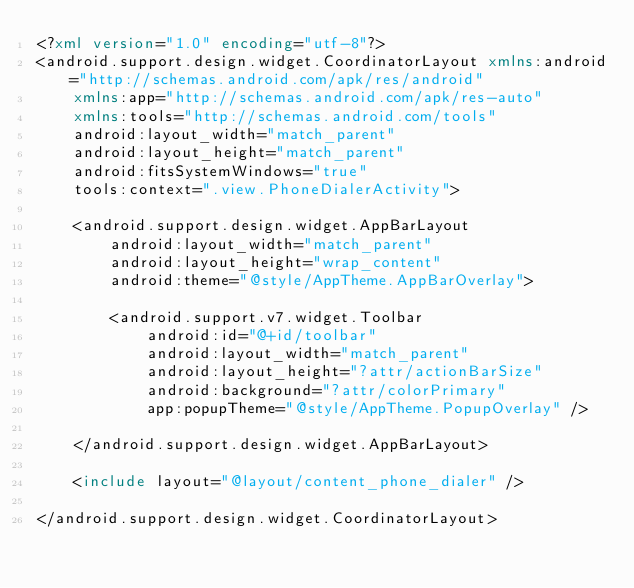Convert code to text. <code><loc_0><loc_0><loc_500><loc_500><_XML_><?xml version="1.0" encoding="utf-8"?>
<android.support.design.widget.CoordinatorLayout xmlns:android="http://schemas.android.com/apk/res/android"
    xmlns:app="http://schemas.android.com/apk/res-auto"
    xmlns:tools="http://schemas.android.com/tools"
    android:layout_width="match_parent"
    android:layout_height="match_parent"
    android:fitsSystemWindows="true"
    tools:context=".view.PhoneDialerActivity">

    <android.support.design.widget.AppBarLayout
        android:layout_width="match_parent"
        android:layout_height="wrap_content"
        android:theme="@style/AppTheme.AppBarOverlay">

        <android.support.v7.widget.Toolbar
            android:id="@+id/toolbar"
            android:layout_width="match_parent"
            android:layout_height="?attr/actionBarSize"
            android:background="?attr/colorPrimary"
            app:popupTheme="@style/AppTheme.PopupOverlay" />

    </android.support.design.widget.AppBarLayout>

    <include layout="@layout/content_phone_dialer" />

</android.support.design.widget.CoordinatorLayout>
</code> 